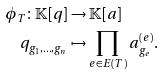<formula> <loc_0><loc_0><loc_500><loc_500>\phi _ { T } \colon \mathbb { K } [ q ] & \rightarrow \mathbb { K } [ a ] \\ q _ { g _ { 1 } , \dots , g _ { n } } & \mapsto \prod _ { e \in E ( T ) } a _ { g _ { e } } ^ { ( e ) } .</formula> 